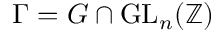Convert formula to latex. <formula><loc_0><loc_0><loc_500><loc_500>\Gamma = G \cap G L _ { n } ( \mathbb { Z } )</formula> 